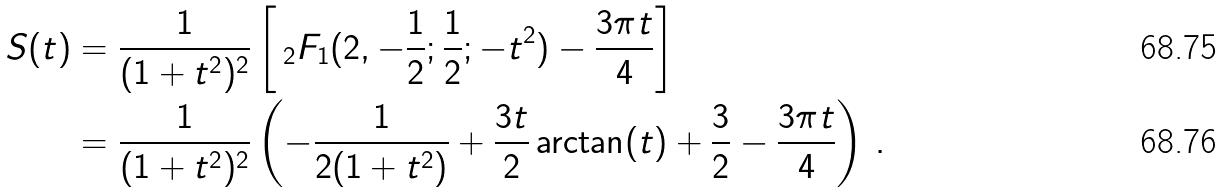<formula> <loc_0><loc_0><loc_500><loc_500>S ( t ) & = \frac { 1 } { ( 1 + t ^ { 2 } ) ^ { 2 } } \left [ \, _ { 2 } F _ { 1 } ( 2 , - \frac { 1 } { 2 } ; \frac { 1 } { 2 } ; - t ^ { 2 } ) - \frac { 3 \pi t } { 4 } \right ] \\ & = \frac { 1 } { ( 1 + t ^ { 2 } ) ^ { 2 } } \left ( - \frac { 1 } { 2 ( 1 + t ^ { 2 } ) } + \frac { 3 t } { 2 } \arctan ( t ) + \frac { 3 } { 2 } - \frac { 3 \pi t } { 4 } \right ) \, .</formula> 